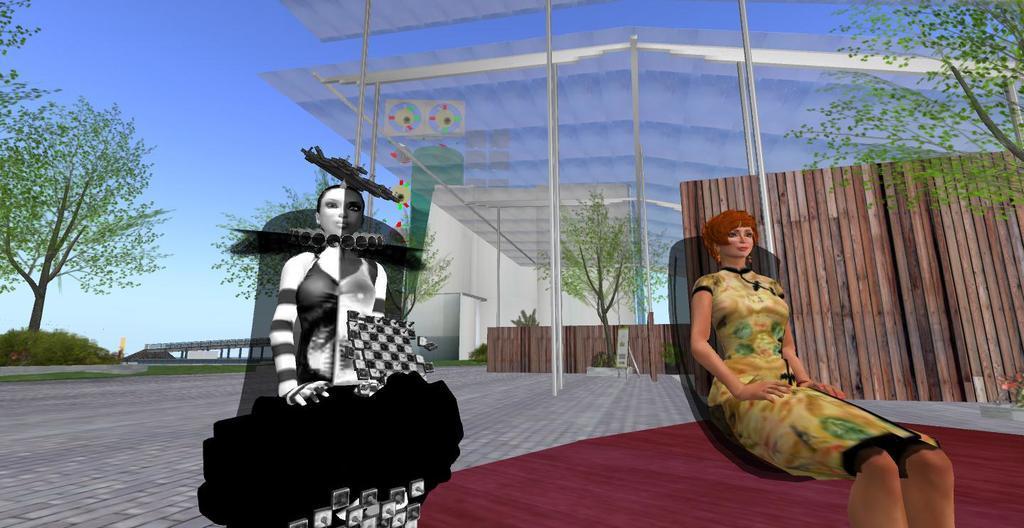How would you summarize this image in a sentence or two? In this image I can see two cartoon persons. The person at right wearing brown color dress, background I can see few glass door, trees in green color and sky in blue color. 